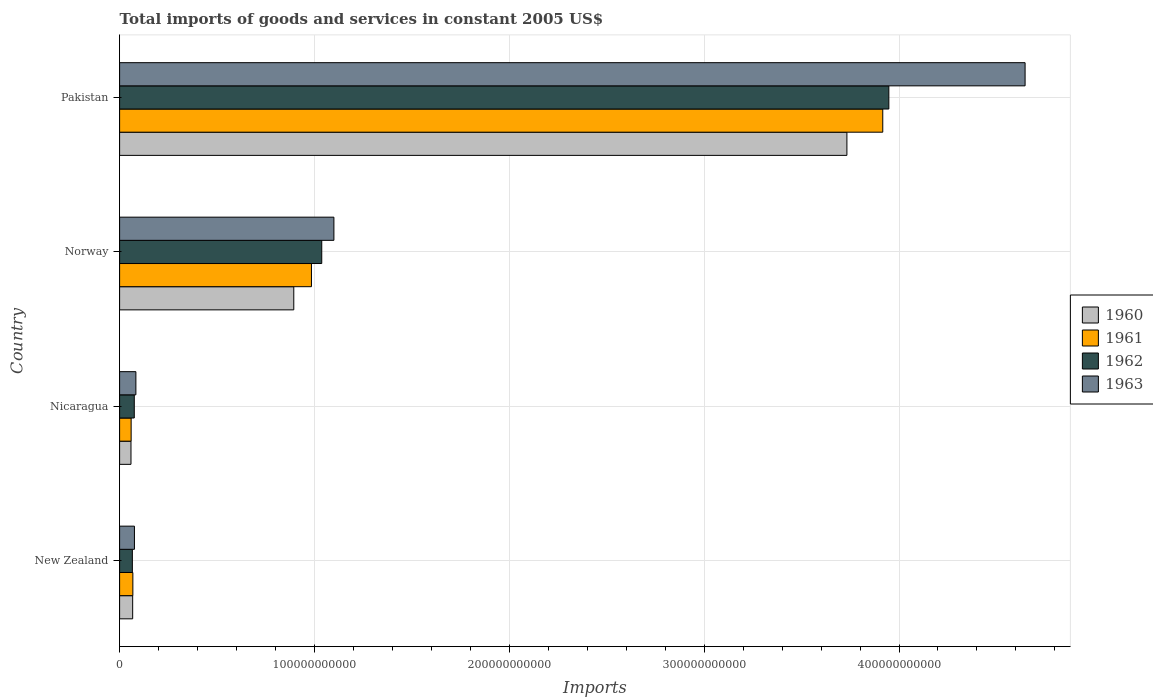How many different coloured bars are there?
Ensure brevity in your answer.  4. How many groups of bars are there?
Make the answer very short. 4. Are the number of bars per tick equal to the number of legend labels?
Provide a short and direct response. Yes. How many bars are there on the 3rd tick from the top?
Make the answer very short. 4. How many bars are there on the 1st tick from the bottom?
Your response must be concise. 4. What is the label of the 3rd group of bars from the top?
Your answer should be very brief. Nicaragua. In how many cases, is the number of bars for a given country not equal to the number of legend labels?
Your answer should be compact. 0. What is the total imports of goods and services in 1960 in New Zealand?
Your response must be concise. 6.71e+09. Across all countries, what is the maximum total imports of goods and services in 1960?
Offer a terse response. 3.73e+11. Across all countries, what is the minimum total imports of goods and services in 1960?
Offer a terse response. 5.84e+09. In which country was the total imports of goods and services in 1963 minimum?
Your answer should be very brief. New Zealand. What is the total total imports of goods and services in 1961 in the graph?
Give a very brief answer. 5.03e+11. What is the difference between the total imports of goods and services in 1962 in Nicaragua and that in Pakistan?
Make the answer very short. -3.87e+11. What is the difference between the total imports of goods and services in 1961 in New Zealand and the total imports of goods and services in 1960 in Norway?
Keep it short and to the point. -8.26e+1. What is the average total imports of goods and services in 1961 per country?
Keep it short and to the point. 1.26e+11. What is the difference between the total imports of goods and services in 1960 and total imports of goods and services in 1961 in New Zealand?
Your answer should be very brief. -9.87e+07. In how many countries, is the total imports of goods and services in 1962 greater than 80000000000 US$?
Ensure brevity in your answer.  2. What is the ratio of the total imports of goods and services in 1962 in Nicaragua to that in Norway?
Ensure brevity in your answer.  0.07. Is the total imports of goods and services in 1961 in Norway less than that in Pakistan?
Ensure brevity in your answer.  Yes. Is the difference between the total imports of goods and services in 1960 in New Zealand and Pakistan greater than the difference between the total imports of goods and services in 1961 in New Zealand and Pakistan?
Give a very brief answer. Yes. What is the difference between the highest and the second highest total imports of goods and services in 1963?
Your answer should be very brief. 3.55e+11. What is the difference between the highest and the lowest total imports of goods and services in 1963?
Ensure brevity in your answer.  4.57e+11. Is it the case that in every country, the sum of the total imports of goods and services in 1960 and total imports of goods and services in 1961 is greater than the sum of total imports of goods and services in 1962 and total imports of goods and services in 1963?
Provide a succinct answer. No. What does the 4th bar from the top in Pakistan represents?
Make the answer very short. 1960. How many bars are there?
Keep it short and to the point. 16. How many countries are there in the graph?
Provide a succinct answer. 4. What is the difference between two consecutive major ticks on the X-axis?
Ensure brevity in your answer.  1.00e+11. Does the graph contain any zero values?
Keep it short and to the point. No. Where does the legend appear in the graph?
Provide a short and direct response. Center right. How many legend labels are there?
Your answer should be compact. 4. How are the legend labels stacked?
Offer a terse response. Vertical. What is the title of the graph?
Offer a very short reply. Total imports of goods and services in constant 2005 US$. What is the label or title of the X-axis?
Keep it short and to the point. Imports. What is the Imports of 1960 in New Zealand?
Offer a very short reply. 6.71e+09. What is the Imports of 1961 in New Zealand?
Your answer should be very brief. 6.81e+09. What is the Imports in 1962 in New Zealand?
Provide a succinct answer. 6.55e+09. What is the Imports of 1963 in New Zealand?
Ensure brevity in your answer.  7.62e+09. What is the Imports of 1960 in Nicaragua?
Make the answer very short. 5.84e+09. What is the Imports of 1961 in Nicaragua?
Make the answer very short. 5.92e+09. What is the Imports of 1962 in Nicaragua?
Offer a very short reply. 7.54e+09. What is the Imports in 1963 in Nicaragua?
Keep it short and to the point. 8.36e+09. What is the Imports in 1960 in Norway?
Give a very brief answer. 8.94e+1. What is the Imports of 1961 in Norway?
Offer a terse response. 9.85e+1. What is the Imports of 1962 in Norway?
Offer a very short reply. 1.04e+11. What is the Imports in 1963 in Norway?
Offer a terse response. 1.10e+11. What is the Imports of 1960 in Pakistan?
Ensure brevity in your answer.  3.73e+11. What is the Imports in 1961 in Pakistan?
Make the answer very short. 3.92e+11. What is the Imports of 1962 in Pakistan?
Keep it short and to the point. 3.95e+11. What is the Imports in 1963 in Pakistan?
Offer a terse response. 4.65e+11. Across all countries, what is the maximum Imports of 1960?
Your answer should be compact. 3.73e+11. Across all countries, what is the maximum Imports in 1961?
Ensure brevity in your answer.  3.92e+11. Across all countries, what is the maximum Imports in 1962?
Keep it short and to the point. 3.95e+11. Across all countries, what is the maximum Imports of 1963?
Keep it short and to the point. 4.65e+11. Across all countries, what is the minimum Imports of 1960?
Ensure brevity in your answer.  5.84e+09. Across all countries, what is the minimum Imports in 1961?
Your answer should be compact. 5.92e+09. Across all countries, what is the minimum Imports in 1962?
Make the answer very short. 6.55e+09. Across all countries, what is the minimum Imports in 1963?
Make the answer very short. 7.62e+09. What is the total Imports of 1960 in the graph?
Provide a short and direct response. 4.75e+11. What is the total Imports of 1961 in the graph?
Make the answer very short. 5.03e+11. What is the total Imports in 1962 in the graph?
Give a very brief answer. 5.13e+11. What is the total Imports of 1963 in the graph?
Your response must be concise. 5.91e+11. What is the difference between the Imports in 1960 in New Zealand and that in Nicaragua?
Your response must be concise. 8.66e+08. What is the difference between the Imports of 1961 in New Zealand and that in Nicaragua?
Provide a short and direct response. 8.81e+08. What is the difference between the Imports of 1962 in New Zealand and that in Nicaragua?
Offer a very short reply. -9.91e+08. What is the difference between the Imports of 1963 in New Zealand and that in Nicaragua?
Your answer should be compact. -7.46e+08. What is the difference between the Imports in 1960 in New Zealand and that in Norway?
Your answer should be very brief. -8.27e+1. What is the difference between the Imports of 1961 in New Zealand and that in Norway?
Provide a succinct answer. -9.17e+1. What is the difference between the Imports of 1962 in New Zealand and that in Norway?
Give a very brief answer. -9.72e+1. What is the difference between the Imports in 1963 in New Zealand and that in Norway?
Your response must be concise. -1.02e+11. What is the difference between the Imports of 1960 in New Zealand and that in Pakistan?
Offer a terse response. -3.67e+11. What is the difference between the Imports of 1961 in New Zealand and that in Pakistan?
Provide a short and direct response. -3.85e+11. What is the difference between the Imports of 1962 in New Zealand and that in Pakistan?
Ensure brevity in your answer.  -3.88e+11. What is the difference between the Imports of 1963 in New Zealand and that in Pakistan?
Your response must be concise. -4.57e+11. What is the difference between the Imports of 1960 in Nicaragua and that in Norway?
Offer a very short reply. -8.35e+1. What is the difference between the Imports in 1961 in Nicaragua and that in Norway?
Offer a terse response. -9.25e+1. What is the difference between the Imports in 1962 in Nicaragua and that in Norway?
Provide a short and direct response. -9.62e+1. What is the difference between the Imports in 1963 in Nicaragua and that in Norway?
Make the answer very short. -1.02e+11. What is the difference between the Imports of 1960 in Nicaragua and that in Pakistan?
Provide a succinct answer. -3.67e+11. What is the difference between the Imports in 1961 in Nicaragua and that in Pakistan?
Make the answer very short. -3.86e+11. What is the difference between the Imports in 1962 in Nicaragua and that in Pakistan?
Ensure brevity in your answer.  -3.87e+11. What is the difference between the Imports of 1963 in Nicaragua and that in Pakistan?
Provide a short and direct response. -4.56e+11. What is the difference between the Imports of 1960 in Norway and that in Pakistan?
Your response must be concise. -2.84e+11. What is the difference between the Imports of 1961 in Norway and that in Pakistan?
Provide a succinct answer. -2.93e+11. What is the difference between the Imports in 1962 in Norway and that in Pakistan?
Ensure brevity in your answer.  -2.91e+11. What is the difference between the Imports of 1963 in Norway and that in Pakistan?
Your answer should be compact. -3.55e+11. What is the difference between the Imports of 1960 in New Zealand and the Imports of 1961 in Nicaragua?
Ensure brevity in your answer.  7.83e+08. What is the difference between the Imports of 1960 in New Zealand and the Imports of 1962 in Nicaragua?
Offer a very short reply. -8.30e+08. What is the difference between the Imports in 1960 in New Zealand and the Imports in 1963 in Nicaragua?
Your response must be concise. -1.66e+09. What is the difference between the Imports in 1961 in New Zealand and the Imports in 1962 in Nicaragua?
Offer a very short reply. -7.32e+08. What is the difference between the Imports of 1961 in New Zealand and the Imports of 1963 in Nicaragua?
Provide a succinct answer. -1.56e+09. What is the difference between the Imports of 1962 in New Zealand and the Imports of 1963 in Nicaragua?
Make the answer very short. -1.82e+09. What is the difference between the Imports of 1960 in New Zealand and the Imports of 1961 in Norway?
Offer a terse response. -9.18e+1. What is the difference between the Imports in 1960 in New Zealand and the Imports in 1962 in Norway?
Keep it short and to the point. -9.70e+1. What is the difference between the Imports in 1960 in New Zealand and the Imports in 1963 in Norway?
Offer a very short reply. -1.03e+11. What is the difference between the Imports of 1961 in New Zealand and the Imports of 1962 in Norway?
Make the answer very short. -9.69e+1. What is the difference between the Imports of 1961 in New Zealand and the Imports of 1963 in Norway?
Give a very brief answer. -1.03e+11. What is the difference between the Imports of 1962 in New Zealand and the Imports of 1963 in Norway?
Ensure brevity in your answer.  -1.03e+11. What is the difference between the Imports of 1960 in New Zealand and the Imports of 1961 in Pakistan?
Offer a terse response. -3.85e+11. What is the difference between the Imports of 1960 in New Zealand and the Imports of 1962 in Pakistan?
Your answer should be compact. -3.88e+11. What is the difference between the Imports in 1960 in New Zealand and the Imports in 1963 in Pakistan?
Ensure brevity in your answer.  -4.58e+11. What is the difference between the Imports of 1961 in New Zealand and the Imports of 1962 in Pakistan?
Keep it short and to the point. -3.88e+11. What is the difference between the Imports in 1961 in New Zealand and the Imports in 1963 in Pakistan?
Your answer should be very brief. -4.58e+11. What is the difference between the Imports of 1962 in New Zealand and the Imports of 1963 in Pakistan?
Give a very brief answer. -4.58e+11. What is the difference between the Imports of 1960 in Nicaragua and the Imports of 1961 in Norway?
Make the answer very short. -9.26e+1. What is the difference between the Imports of 1960 in Nicaragua and the Imports of 1962 in Norway?
Your response must be concise. -9.79e+1. What is the difference between the Imports of 1960 in Nicaragua and the Imports of 1963 in Norway?
Give a very brief answer. -1.04e+11. What is the difference between the Imports of 1961 in Nicaragua and the Imports of 1962 in Norway?
Keep it short and to the point. -9.78e+1. What is the difference between the Imports of 1961 in Nicaragua and the Imports of 1963 in Norway?
Offer a terse response. -1.04e+11. What is the difference between the Imports of 1962 in Nicaragua and the Imports of 1963 in Norway?
Provide a succinct answer. -1.02e+11. What is the difference between the Imports of 1960 in Nicaragua and the Imports of 1961 in Pakistan?
Give a very brief answer. -3.86e+11. What is the difference between the Imports in 1960 in Nicaragua and the Imports in 1962 in Pakistan?
Offer a very short reply. -3.89e+11. What is the difference between the Imports in 1960 in Nicaragua and the Imports in 1963 in Pakistan?
Your answer should be compact. -4.59e+11. What is the difference between the Imports of 1961 in Nicaragua and the Imports of 1962 in Pakistan?
Provide a succinct answer. -3.89e+11. What is the difference between the Imports in 1961 in Nicaragua and the Imports in 1963 in Pakistan?
Give a very brief answer. -4.59e+11. What is the difference between the Imports in 1962 in Nicaragua and the Imports in 1963 in Pakistan?
Ensure brevity in your answer.  -4.57e+11. What is the difference between the Imports of 1960 in Norway and the Imports of 1961 in Pakistan?
Make the answer very short. -3.02e+11. What is the difference between the Imports of 1960 in Norway and the Imports of 1962 in Pakistan?
Provide a succinct answer. -3.05e+11. What is the difference between the Imports of 1960 in Norway and the Imports of 1963 in Pakistan?
Your answer should be very brief. -3.75e+11. What is the difference between the Imports in 1961 in Norway and the Imports in 1962 in Pakistan?
Offer a very short reply. -2.96e+11. What is the difference between the Imports of 1961 in Norway and the Imports of 1963 in Pakistan?
Make the answer very short. -3.66e+11. What is the difference between the Imports of 1962 in Norway and the Imports of 1963 in Pakistan?
Make the answer very short. -3.61e+11. What is the average Imports in 1960 per country?
Provide a short and direct response. 1.19e+11. What is the average Imports of 1961 per country?
Offer a very short reply. 1.26e+11. What is the average Imports of 1962 per country?
Give a very brief answer. 1.28e+11. What is the average Imports of 1963 per country?
Your answer should be very brief. 1.48e+11. What is the difference between the Imports in 1960 and Imports in 1961 in New Zealand?
Offer a very short reply. -9.87e+07. What is the difference between the Imports in 1960 and Imports in 1962 in New Zealand?
Your response must be concise. 1.61e+08. What is the difference between the Imports of 1960 and Imports of 1963 in New Zealand?
Offer a very short reply. -9.09e+08. What is the difference between the Imports in 1961 and Imports in 1962 in New Zealand?
Make the answer very short. 2.60e+08. What is the difference between the Imports of 1961 and Imports of 1963 in New Zealand?
Your answer should be compact. -8.10e+08. What is the difference between the Imports of 1962 and Imports of 1963 in New Zealand?
Offer a terse response. -1.07e+09. What is the difference between the Imports in 1960 and Imports in 1961 in Nicaragua?
Keep it short and to the point. -8.34e+07. What is the difference between the Imports in 1960 and Imports in 1962 in Nicaragua?
Provide a succinct answer. -1.70e+09. What is the difference between the Imports in 1960 and Imports in 1963 in Nicaragua?
Give a very brief answer. -2.52e+09. What is the difference between the Imports of 1961 and Imports of 1962 in Nicaragua?
Offer a terse response. -1.61e+09. What is the difference between the Imports in 1961 and Imports in 1963 in Nicaragua?
Your answer should be very brief. -2.44e+09. What is the difference between the Imports in 1962 and Imports in 1963 in Nicaragua?
Your response must be concise. -8.25e+08. What is the difference between the Imports in 1960 and Imports in 1961 in Norway?
Your answer should be compact. -9.07e+09. What is the difference between the Imports of 1960 and Imports of 1962 in Norway?
Your response must be concise. -1.44e+1. What is the difference between the Imports in 1960 and Imports in 1963 in Norway?
Make the answer very short. -2.06e+1. What is the difference between the Imports in 1961 and Imports in 1962 in Norway?
Provide a succinct answer. -5.28e+09. What is the difference between the Imports in 1961 and Imports in 1963 in Norway?
Make the answer very short. -1.15e+1. What is the difference between the Imports in 1962 and Imports in 1963 in Norway?
Provide a short and direct response. -6.24e+09. What is the difference between the Imports in 1960 and Imports in 1961 in Pakistan?
Ensure brevity in your answer.  -1.84e+1. What is the difference between the Imports of 1960 and Imports of 1962 in Pakistan?
Your response must be concise. -2.15e+1. What is the difference between the Imports in 1960 and Imports in 1963 in Pakistan?
Provide a short and direct response. -9.14e+1. What is the difference between the Imports in 1961 and Imports in 1962 in Pakistan?
Give a very brief answer. -3.12e+09. What is the difference between the Imports in 1961 and Imports in 1963 in Pakistan?
Provide a succinct answer. -7.30e+1. What is the difference between the Imports in 1962 and Imports in 1963 in Pakistan?
Make the answer very short. -6.99e+1. What is the ratio of the Imports in 1960 in New Zealand to that in Nicaragua?
Provide a succinct answer. 1.15. What is the ratio of the Imports of 1961 in New Zealand to that in Nicaragua?
Give a very brief answer. 1.15. What is the ratio of the Imports in 1962 in New Zealand to that in Nicaragua?
Your answer should be compact. 0.87. What is the ratio of the Imports of 1963 in New Zealand to that in Nicaragua?
Offer a terse response. 0.91. What is the ratio of the Imports in 1960 in New Zealand to that in Norway?
Your answer should be compact. 0.07. What is the ratio of the Imports of 1961 in New Zealand to that in Norway?
Make the answer very short. 0.07. What is the ratio of the Imports of 1962 in New Zealand to that in Norway?
Provide a short and direct response. 0.06. What is the ratio of the Imports in 1963 in New Zealand to that in Norway?
Provide a short and direct response. 0.07. What is the ratio of the Imports in 1960 in New Zealand to that in Pakistan?
Offer a very short reply. 0.02. What is the ratio of the Imports of 1961 in New Zealand to that in Pakistan?
Keep it short and to the point. 0.02. What is the ratio of the Imports of 1962 in New Zealand to that in Pakistan?
Ensure brevity in your answer.  0.02. What is the ratio of the Imports in 1963 in New Zealand to that in Pakistan?
Keep it short and to the point. 0.02. What is the ratio of the Imports in 1960 in Nicaragua to that in Norway?
Offer a terse response. 0.07. What is the ratio of the Imports of 1961 in Nicaragua to that in Norway?
Offer a very short reply. 0.06. What is the ratio of the Imports of 1962 in Nicaragua to that in Norway?
Give a very brief answer. 0.07. What is the ratio of the Imports in 1963 in Nicaragua to that in Norway?
Ensure brevity in your answer.  0.08. What is the ratio of the Imports of 1960 in Nicaragua to that in Pakistan?
Provide a succinct answer. 0.02. What is the ratio of the Imports of 1961 in Nicaragua to that in Pakistan?
Your response must be concise. 0.02. What is the ratio of the Imports of 1962 in Nicaragua to that in Pakistan?
Your answer should be very brief. 0.02. What is the ratio of the Imports of 1963 in Nicaragua to that in Pakistan?
Your response must be concise. 0.02. What is the ratio of the Imports in 1960 in Norway to that in Pakistan?
Offer a very short reply. 0.24. What is the ratio of the Imports in 1961 in Norway to that in Pakistan?
Make the answer very short. 0.25. What is the ratio of the Imports in 1962 in Norway to that in Pakistan?
Make the answer very short. 0.26. What is the ratio of the Imports of 1963 in Norway to that in Pakistan?
Your answer should be very brief. 0.24. What is the difference between the highest and the second highest Imports in 1960?
Provide a short and direct response. 2.84e+11. What is the difference between the highest and the second highest Imports in 1961?
Provide a succinct answer. 2.93e+11. What is the difference between the highest and the second highest Imports of 1962?
Your answer should be compact. 2.91e+11. What is the difference between the highest and the second highest Imports in 1963?
Make the answer very short. 3.55e+11. What is the difference between the highest and the lowest Imports of 1960?
Your answer should be compact. 3.67e+11. What is the difference between the highest and the lowest Imports of 1961?
Ensure brevity in your answer.  3.86e+11. What is the difference between the highest and the lowest Imports of 1962?
Your answer should be very brief. 3.88e+11. What is the difference between the highest and the lowest Imports in 1963?
Ensure brevity in your answer.  4.57e+11. 